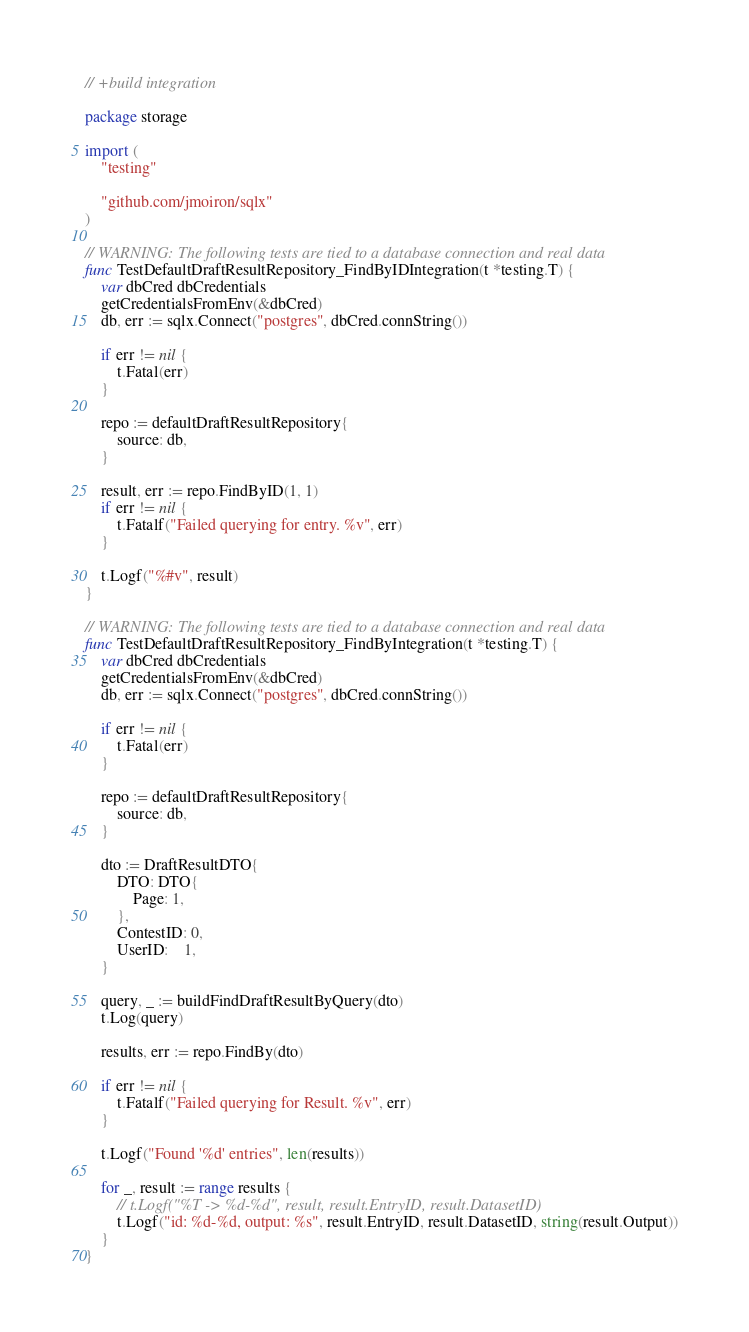<code> <loc_0><loc_0><loc_500><loc_500><_Go_>// +build integration

package storage

import (
	"testing"

	"github.com/jmoiron/sqlx"
)

// WARNING: The following tests are tied to a database connection and real data
func TestDefaultDraftResultRepository_FindByIDIntegration(t *testing.T) {
	var dbCred dbCredentials
	getCredentialsFromEnv(&dbCred)
	db, err := sqlx.Connect("postgres", dbCred.connString())

	if err != nil {
		t.Fatal(err)
	}

	repo := defaultDraftResultRepository{
		source: db,
	}

	result, err := repo.FindByID(1, 1)
	if err != nil {
		t.Fatalf("Failed querying for entry. %v", err)
	}

	t.Logf("%#v", result)
}

// WARNING: The following tests are tied to a database connection and real data
func TestDefaultDraftResultRepository_FindByIntegration(t *testing.T) {
	var dbCred dbCredentials
	getCredentialsFromEnv(&dbCred)
	db, err := sqlx.Connect("postgres", dbCred.connString())

	if err != nil {
		t.Fatal(err)
	}

	repo := defaultDraftResultRepository{
		source: db,
	}

	dto := DraftResultDTO{
		DTO: DTO{
			Page: 1,
		},
		ContestID: 0,
		UserID:    1,
	}

	query, _ := buildFindDraftResultByQuery(dto)
	t.Log(query)

	results, err := repo.FindBy(dto)

	if err != nil {
		t.Fatalf("Failed querying for Result. %v", err)
	}

	t.Logf("Found '%d' entries", len(results))

	for _, result := range results {
		// t.Logf("%T -> %d-%d", result, result.EntryID, result.DatasetID)
		t.Logf("id: %d-%d, output: %s", result.EntryID, result.DatasetID, string(result.Output))
	}
}
</code> 